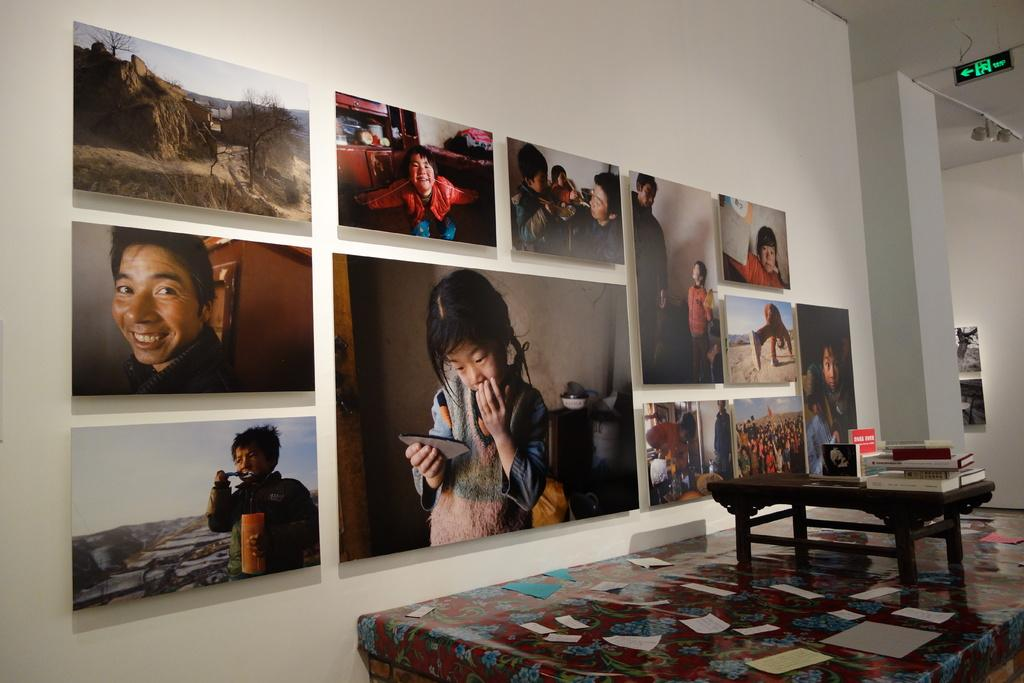What type of furniture is present in the image? There is a table in the image. What can be seen on the wall in the image? There is a poster on the wall. Can you describe the background of the image? The background of the image includes a wall with a poster on it. What type of advertisement is visible on the wall in the image? There is no advertisement visible on the wall in the image; it features a poster. How does the boot interact with the wall in the image? There is no boot present in the image, so it cannot interact with the wall. 